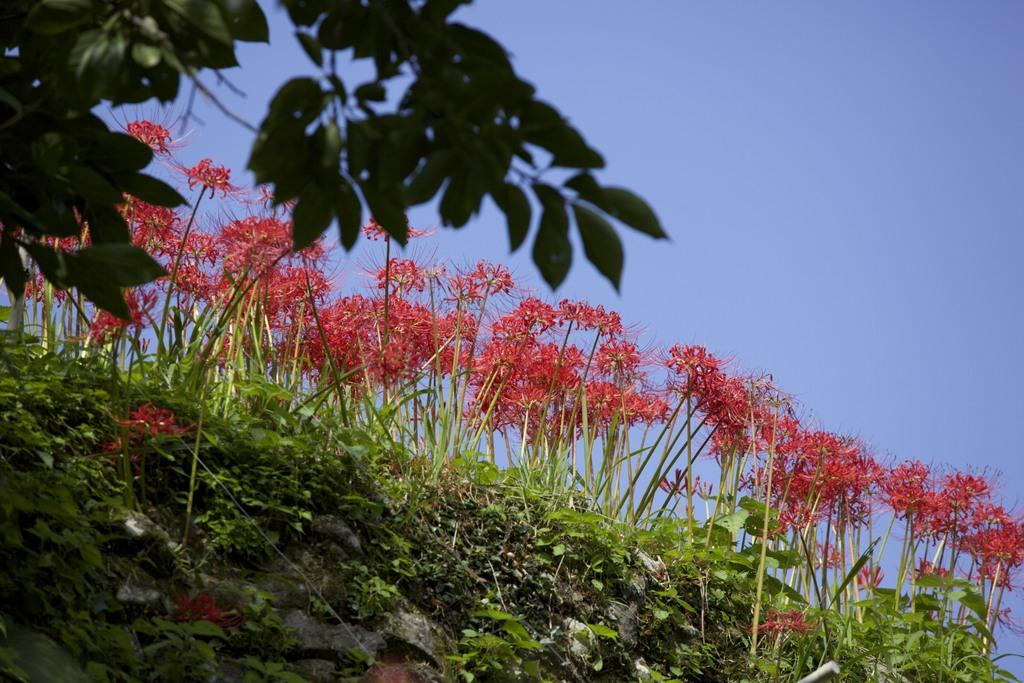What type of vegetation can be seen in the image? There is grass in the image. What color are the flowers in the image? The flowers in the image are red-colored. Where are the green-colored leaves located in the image? The green-colored leaves are on the top left side of the image. What can be seen in the background of the image? The sky is visible in the background of the image. What type of toothbrush is being used to clean the appliance in the image? There is no toothbrush or appliance present in the image. 